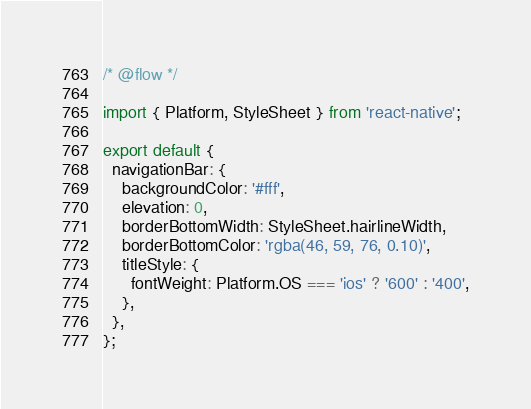Convert code to text. <code><loc_0><loc_0><loc_500><loc_500><_JavaScript_>/* @flow */

import { Platform, StyleSheet } from 'react-native';

export default {
  navigationBar: {
    backgroundColor: '#fff',
    elevation: 0,
    borderBottomWidth: StyleSheet.hairlineWidth,
    borderBottomColor: 'rgba(46, 59, 76, 0.10)',
    titleStyle: {
      fontWeight: Platform.OS === 'ios' ? '600' : '400',
    },
  },
};
</code> 